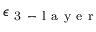<formula> <loc_0><loc_0><loc_500><loc_500>\epsilon _ { 3 - l a y e r }</formula> 